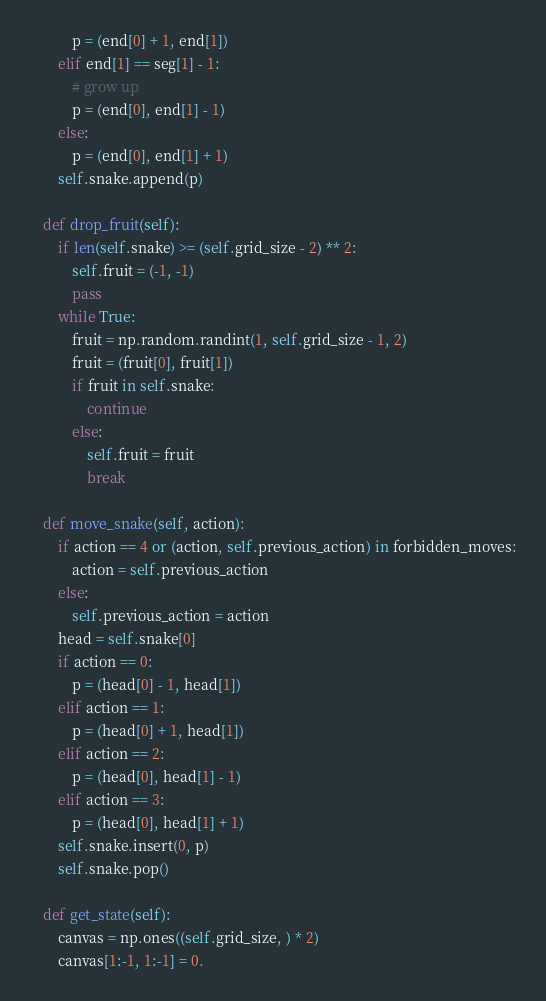<code> <loc_0><loc_0><loc_500><loc_500><_Python_>            p = (end[0] + 1, end[1])
        elif end[1] == seg[1] - 1:
            # grow up
            p = (end[0], end[1] - 1)
        else:
            p = (end[0], end[1] + 1)
        self.snake.append(p)

    def drop_fruit(self):
        if len(self.snake) >= (self.grid_size - 2) ** 2:
            self.fruit = (-1, -1)
            pass
        while True:
            fruit = np.random.randint(1, self.grid_size - 1, 2)
            fruit = (fruit[0], fruit[1])
            if fruit in self.snake:
                continue
            else:
                self.fruit = fruit
                break

    def move_snake(self, action):
        if action == 4 or (action, self.previous_action) in forbidden_moves:
            action = self.previous_action
        else:
            self.previous_action = action
        head = self.snake[0]
        if action == 0:
            p = (head[0] - 1, head[1])
        elif action == 1:
            p = (head[0] + 1, head[1])
        elif action == 2:
            p = (head[0], head[1] - 1)
        elif action == 3:
            p = (head[0], head[1] + 1)
        self.snake.insert(0, p)
        self.snake.pop()

    def get_state(self):
        canvas = np.ones((self.grid_size, ) * 2)
        canvas[1:-1, 1:-1] = 0.</code> 